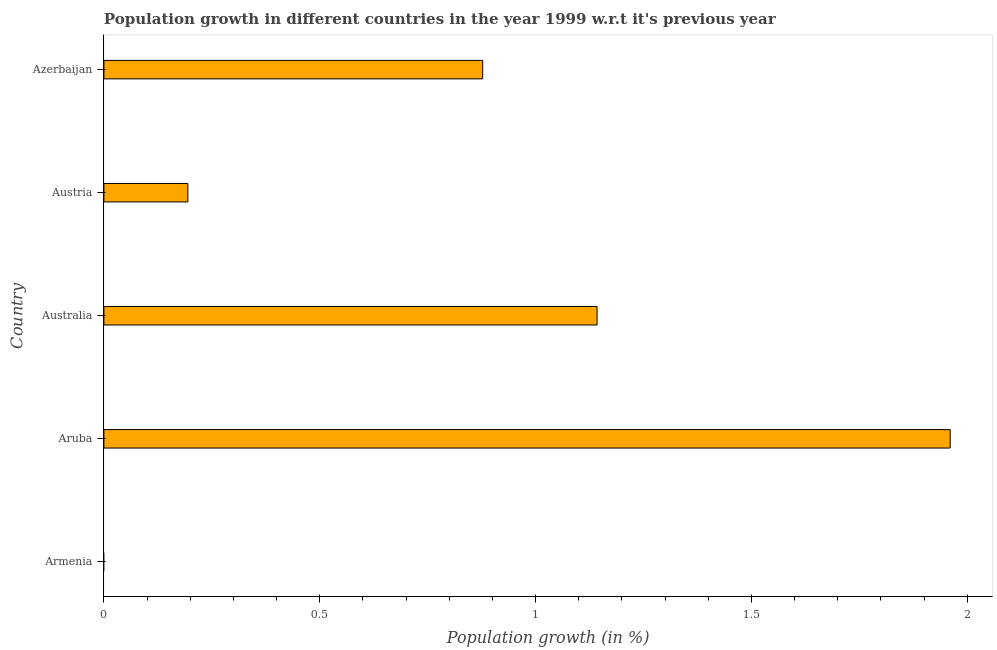Does the graph contain any zero values?
Make the answer very short. Yes. Does the graph contain grids?
Your answer should be very brief. No. What is the title of the graph?
Provide a short and direct response. Population growth in different countries in the year 1999 w.r.t it's previous year. What is the label or title of the X-axis?
Provide a short and direct response. Population growth (in %). What is the label or title of the Y-axis?
Offer a terse response. Country. What is the population growth in Austria?
Offer a very short reply. 0.19. Across all countries, what is the maximum population growth?
Give a very brief answer. 1.96. Across all countries, what is the minimum population growth?
Your answer should be very brief. 0. In which country was the population growth maximum?
Offer a very short reply. Aruba. What is the sum of the population growth?
Provide a short and direct response. 4.18. What is the difference between the population growth in Aruba and Australia?
Your response must be concise. 0.82. What is the average population growth per country?
Offer a very short reply. 0.83. What is the median population growth?
Offer a terse response. 0.88. In how many countries, is the population growth greater than 1.6 %?
Provide a succinct answer. 1. What is the ratio of the population growth in Aruba to that in Australia?
Give a very brief answer. 1.72. Is the difference between the population growth in Australia and Austria greater than the difference between any two countries?
Provide a short and direct response. No. What is the difference between the highest and the second highest population growth?
Offer a terse response. 0.82. What is the difference between the highest and the lowest population growth?
Make the answer very short. 1.96. In how many countries, is the population growth greater than the average population growth taken over all countries?
Provide a short and direct response. 3. Are all the bars in the graph horizontal?
Your response must be concise. Yes. What is the difference between two consecutive major ticks on the X-axis?
Your response must be concise. 0.5. What is the Population growth (in %) in Armenia?
Provide a succinct answer. 0. What is the Population growth (in %) of Aruba?
Your answer should be compact. 1.96. What is the Population growth (in %) in Australia?
Make the answer very short. 1.14. What is the Population growth (in %) in Austria?
Ensure brevity in your answer.  0.19. What is the Population growth (in %) in Azerbaijan?
Your answer should be very brief. 0.88. What is the difference between the Population growth (in %) in Aruba and Australia?
Offer a very short reply. 0.82. What is the difference between the Population growth (in %) in Aruba and Austria?
Your response must be concise. 1.77. What is the difference between the Population growth (in %) in Aruba and Azerbaijan?
Provide a succinct answer. 1.08. What is the difference between the Population growth (in %) in Australia and Austria?
Your answer should be compact. 0.95. What is the difference between the Population growth (in %) in Australia and Azerbaijan?
Ensure brevity in your answer.  0.26. What is the difference between the Population growth (in %) in Austria and Azerbaijan?
Offer a very short reply. -0.68. What is the ratio of the Population growth (in %) in Aruba to that in Australia?
Provide a succinct answer. 1.72. What is the ratio of the Population growth (in %) in Aruba to that in Austria?
Ensure brevity in your answer.  10.08. What is the ratio of the Population growth (in %) in Aruba to that in Azerbaijan?
Your answer should be compact. 2.23. What is the ratio of the Population growth (in %) in Australia to that in Austria?
Your answer should be compact. 5.87. What is the ratio of the Population growth (in %) in Australia to that in Azerbaijan?
Offer a terse response. 1.3. What is the ratio of the Population growth (in %) in Austria to that in Azerbaijan?
Keep it short and to the point. 0.22. 